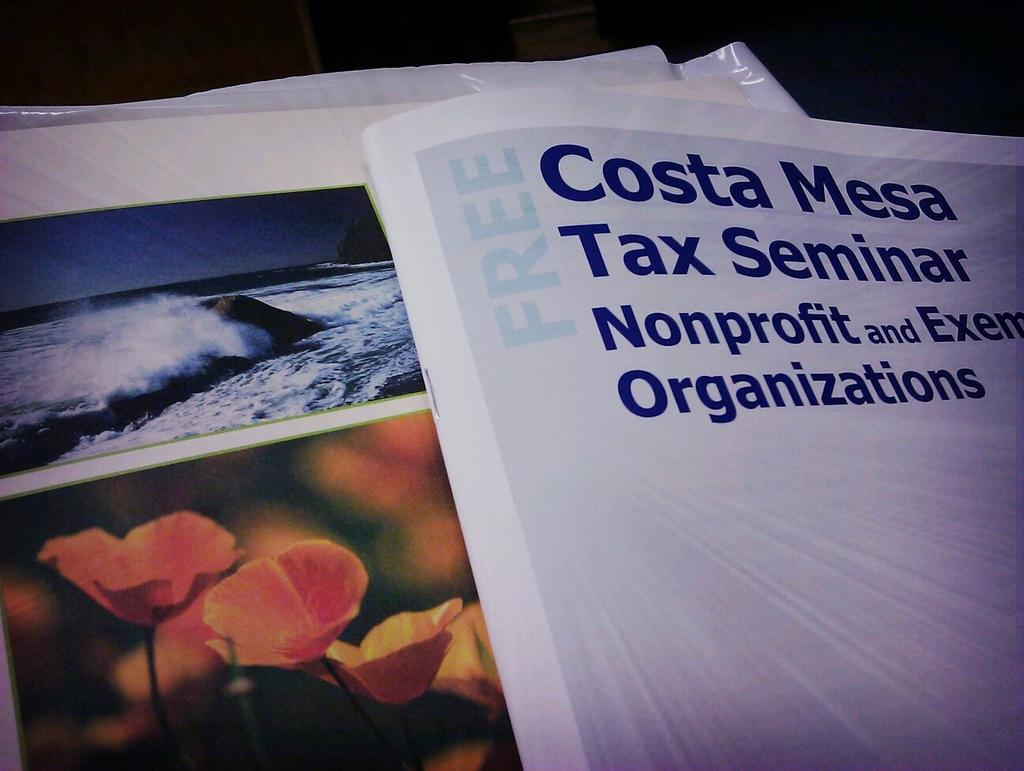What objects are present in the image? There are books in the image. What type of content can be found in the books? The books contain text and images. How many legs does the animal have in the image? There is no animal present in the image, so it is not possible to determine the number of legs it might have. 